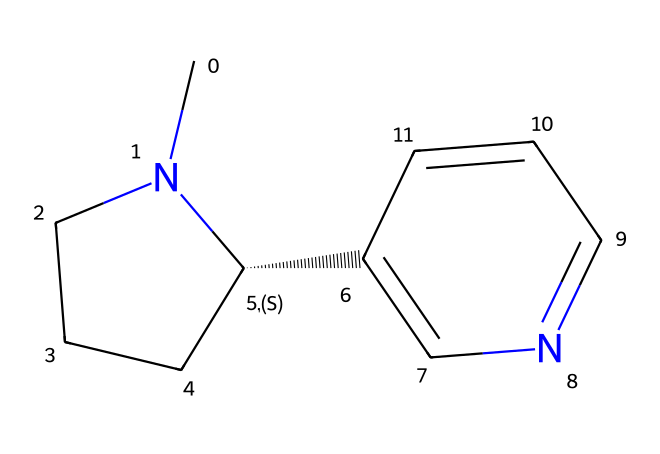What is the name of this chemical? The chemical represented in the SMILES provided is nicotine. This can be determined by looking up the SMILES and matching it with known chemical structures.
Answer: nicotine How many nitrogen atoms are in nicotine? By analyzing the molecular structure, we can identify that there are two nitrogen atoms present. They can be seen in the cyclic structure and the linear part.
Answer: two What type of drug is nicotine classified as? Nicotine is classified as a stimulant. This can be concluded from its pharmacological effects, which include increased alertness and relaxation, typical of stimulant drugs.
Answer: stimulant What happens when nicotine binds to its receptors? When nicotine binds to its acetylcholine receptors, it stimulates the release of dopamine, leading to pleasurable sensations. This function is a primary reason for its addictive properties.
Answer: releases dopamine How does the structure of nicotine relate to its addiction potential? The presence of the nitrogen atoms allows nicotine to interact effectively with the neurotransmitter systems in the brain, particularly the dopamine pathway, which enhances its addictive potential.
Answer: interacts with neurotransmitters What functional group is primarily responsible for the basicity of nicotine? The basicity of nicotine is mainly due to the pyridine nitrogen, which has a lone pair of electrons that can accept protons, making it a basic compound.
Answer: pyridine nitrogen 